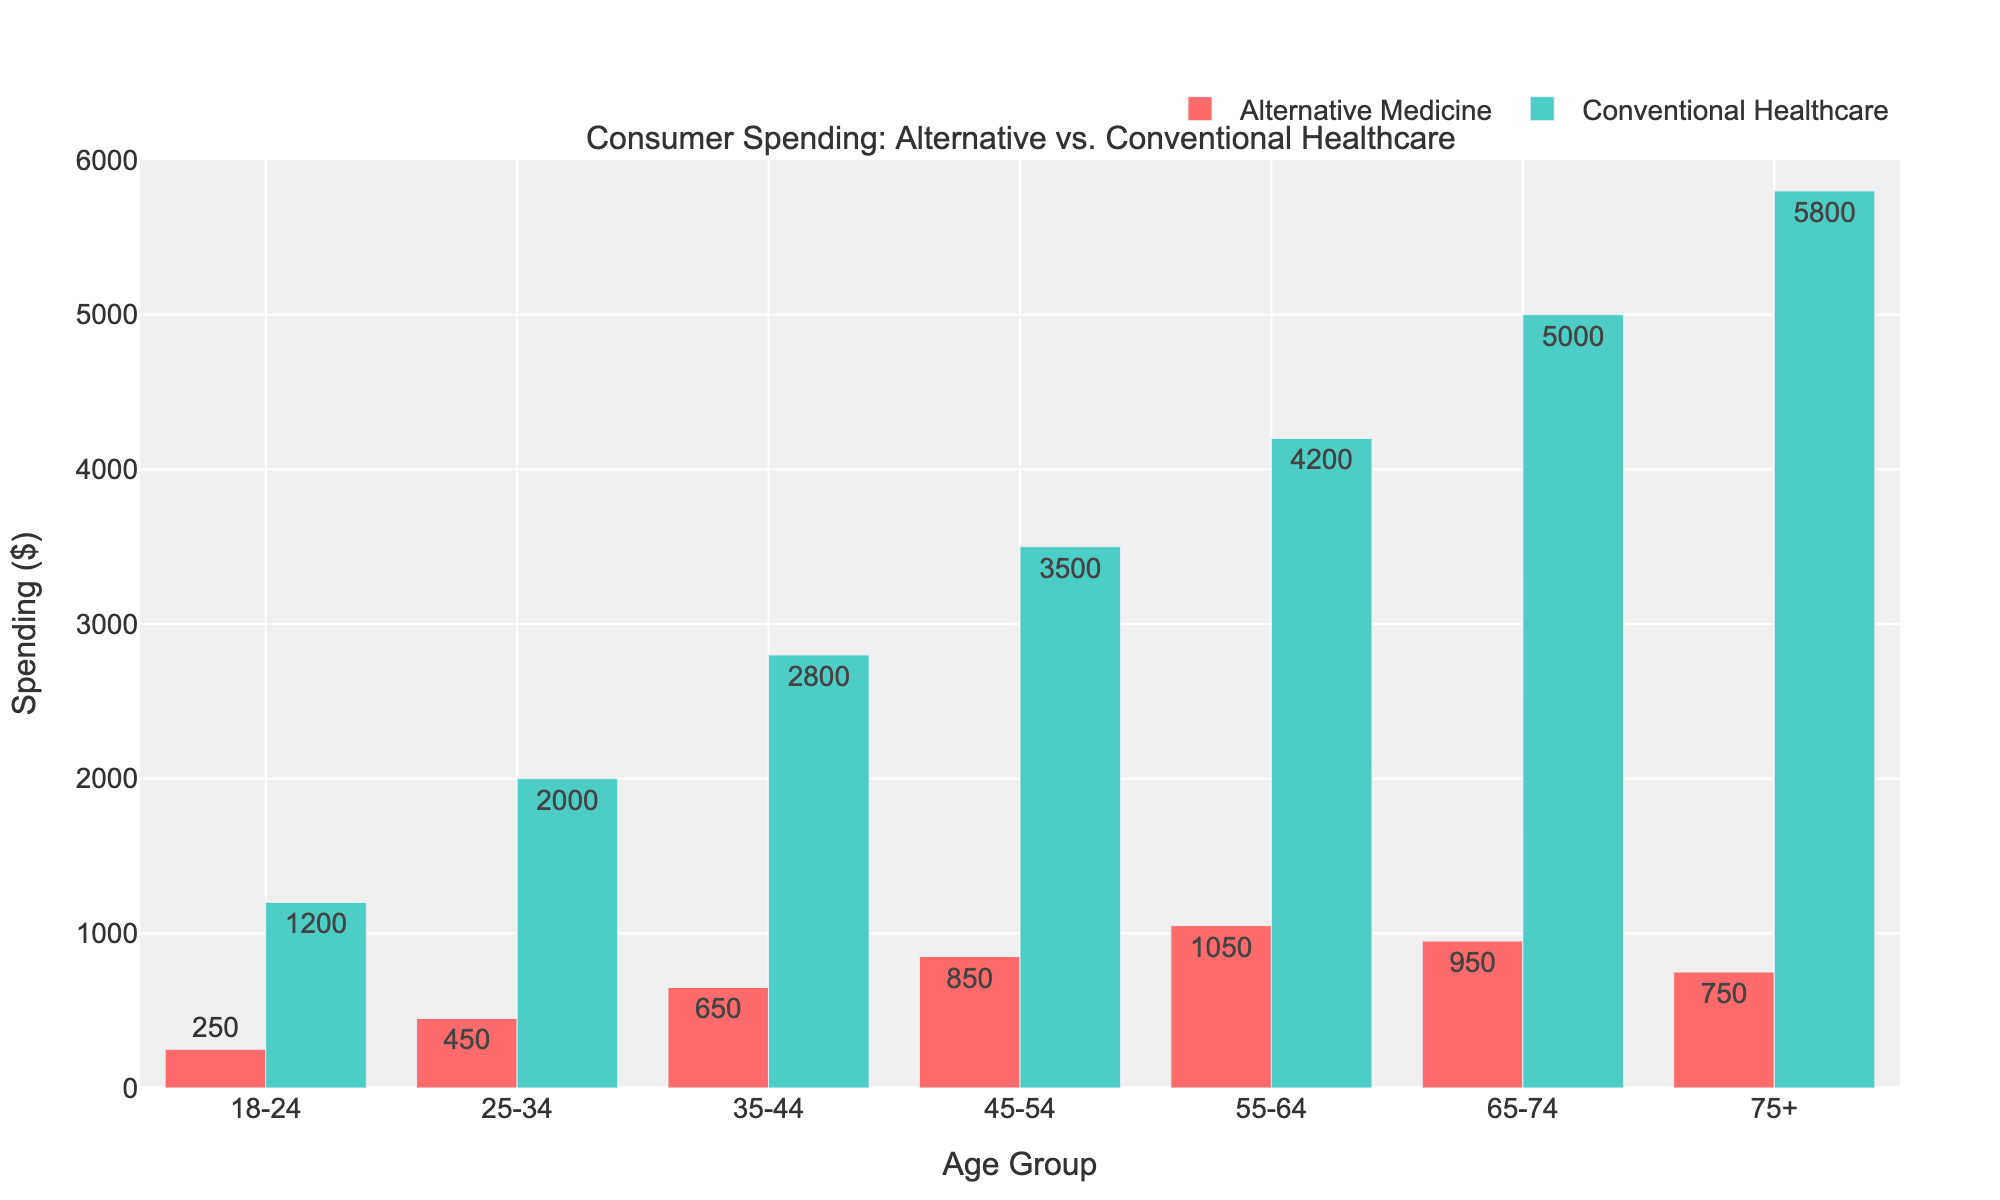Which age group spends the most on conventional healthcare? By looking at the heights of the bars for conventional healthcare (green bars), the tallest bar is for the "75+" age group.
Answer: 75+ What is the difference in spending on alternative medicine between the 45-54 age group and the 65-74 age group? The spending for the 45-54 age group on alternative medicine is $850, and for the 65-74 age group, it is $950. The difference is $950 - $850.
Answer: 100 How does spending on conventional healthcare for the 25-34 age group compare to that of the 55-64 age group? The spending for the 25-34 age group is $2000, while for the 55-64 age group, it is $4200. The $4200 is significantly higher than $2000.
Answer: 55-64 spends more Which age group shows the smallest difference between alternative medicine and conventional healthcare spending? By visual inspection, the gap between the red and green bars is smallest for the "65-74" age group.
Answer: 65-74 What is the sum of spending on alternative medicine for the 18-24 and 35-44 age groups? The spending for the 18-24 age group is $250, and for the 35-44 age group, it is $650. The sum is $250 + $650.
Answer: 900 Which age group has the highest combined spending on alternative medicine and conventional healthcare? Adding the values for each age group, the 75+ group has the highest combined spending: $750 + $5800 = $6550.
Answer: 75+ What is the ratio of conventional healthcare spending to alternative medicine spending for the 45-54 age group? The spending on conventional healthcare for the 45-54 age group is $3500, and for alternative medicine, it is $850. The ratio is $3500 / $850.
Answer: 4.12 How does the total spending on alternative medicine across all age groups compare to the total spending on conventional healthcare? Summing up values for all age groups, alternative medicine: 250 + 450 + 650 + 850 + 1050 + 950 + 750 = $4950; conventional: 1200 + 2000 + 2800 + 3500 + 4200 + 5000 + 5800 = $24500. Conventional healthcare spending is much higher.
Answer: Conventional healthcare is much higher What percentage of the total spending on alternative medicine does the 55-64 age group represent? The 55-64 age group spends $1050 on alternative medicine. Total alternative medicine spending is $4950. The percentage is ($1050 / $4950) * 100%.
Answer: 21.21% For which age group is the increase in spending from alternative medicine to conventional healthcare the greatest? Calculate the difference between conventional healthcare and alternative medicine for each age group. The 75+ group has the greatest gap: $5800 - $750.
Answer: 75+ 